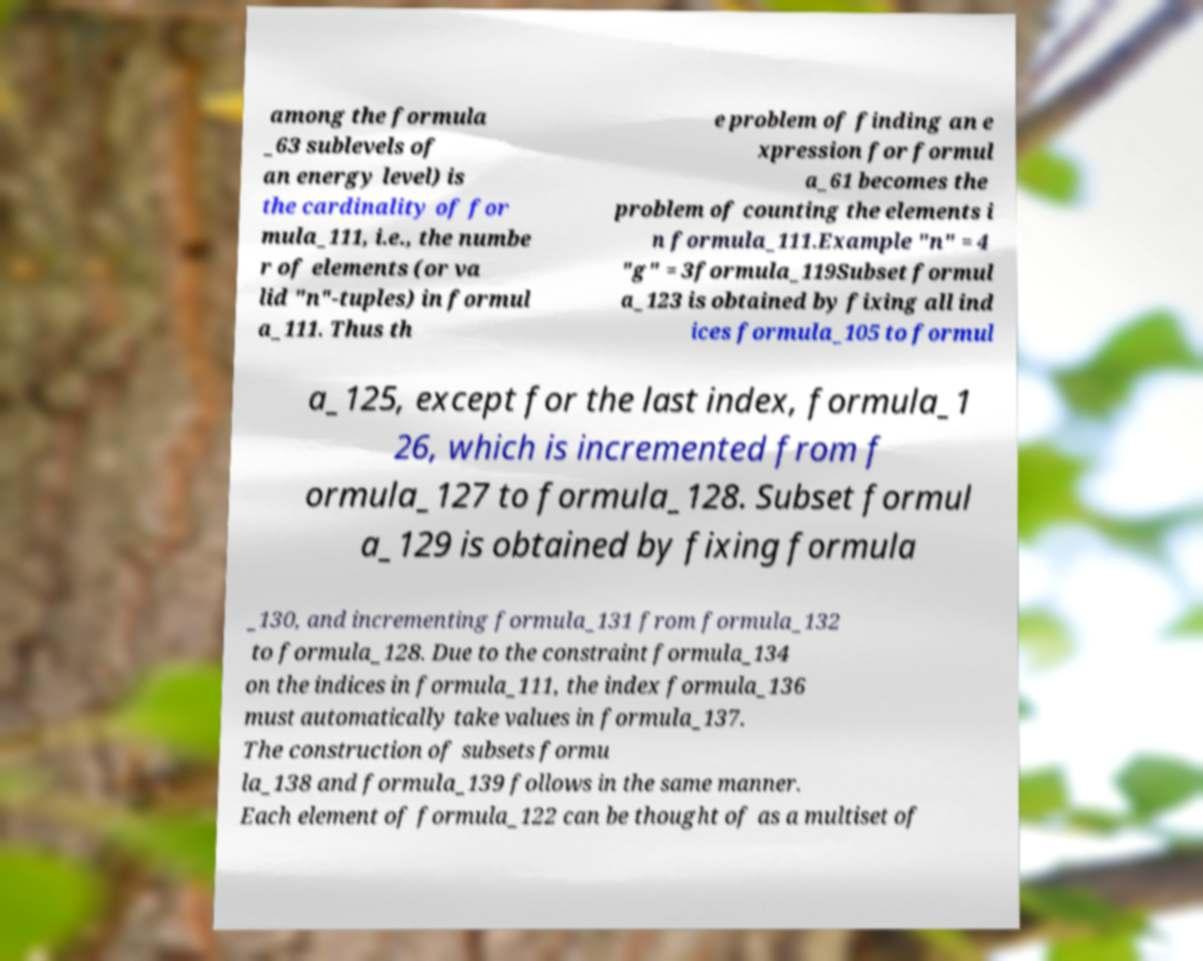Can you accurately transcribe the text from the provided image for me? among the formula _63 sublevels of an energy level) is the cardinality of for mula_111, i.e., the numbe r of elements (or va lid "n"-tuples) in formul a_111. Thus th e problem of finding an e xpression for formul a_61 becomes the problem of counting the elements i n formula_111.Example "n" = 4 "g" = 3formula_119Subset formul a_123 is obtained by fixing all ind ices formula_105 to formul a_125, except for the last index, formula_1 26, which is incremented from f ormula_127 to formula_128. Subset formul a_129 is obtained by fixing formula _130, and incrementing formula_131 from formula_132 to formula_128. Due to the constraint formula_134 on the indices in formula_111, the index formula_136 must automatically take values in formula_137. The construction of subsets formu la_138 and formula_139 follows in the same manner. Each element of formula_122 can be thought of as a multiset of 